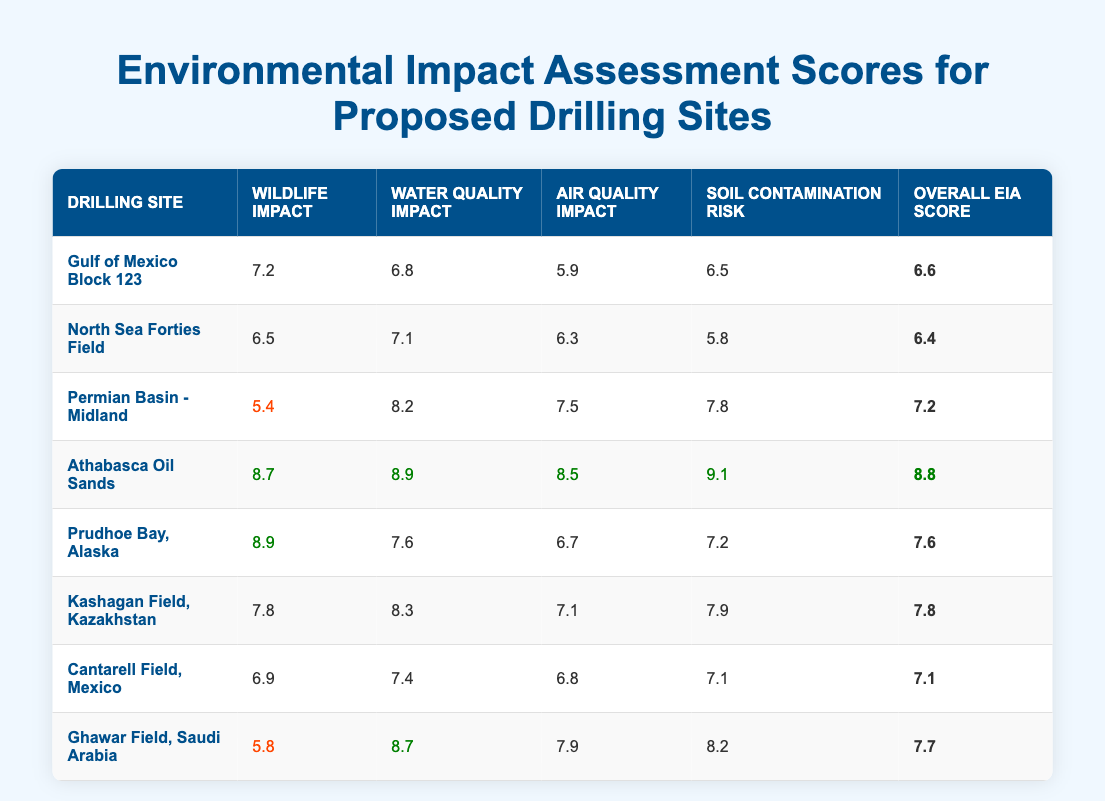What is the Overall EIA Score for the Athabasca Oil Sands? The Overall EIA Score for the Athabasca Oil Sands is provided directly in the table. Looking at the row for Athabasca Oil Sands, the score listed is 8.8.
Answer: 8.8 Which drilling site has the highest Air Quality Impact score? To determine the site with the highest Air Quality Impact score, we look at the Air Quality Impact column and find the maximum value. Athabasca Oil Sands has the highest score of 8.5.
Answer: Athabasca Oil Sands What is the average Wildlife Impact score for all drilling sites? To find the average, we sum the Wildlife Impact scores (7.2 + 6.5 + 5.4 + 8.7 + 8.9 + 7.8 + 6.9 + 5.8) = 56.2. There are 8 drilling sites, so we divide the sum by 8. Thus, the average is 56.2 / 8 = 7.025.
Answer: 7.025 Is the Water Quality Impact for the Gulf of Mexico Block 123 above 6? To answer this, we check the Water Quality Impact score for Gulf of Mexico Block 123. The score is 6.8, which is indeed above 6.
Answer: Yes Which drilling site has the lowest Overall EIA Score? First, we check the Overall EIA Score column for all sites and identify the lowest value listed. The lowest Overall EIA Score is 6.4 for the North Sea Forties Field.
Answer: North Sea Forties Field How does the Soil Contamination Risk compare between the Athabasca Oil Sands and Prudhoe Bay, Alaska? We look at the Soil Contamination Risk scores for both drilling sites. Athabasca Oil Sands has a risk score of 9.1, while Prudhoe Bay has a score of 7.2. Thus, the Athabasca Oil Sands has a higher Soil Contamination Risk by 1.9 points.
Answer: Athabasca Oil Sands has a higher risk What is the total score from Wildlife Impact for the Ghawar Field and the Permian Basin - Midland combined? We add the Wildlife Impact scores for both sites: Ghawar Field has a score of 5.8 and Permian Basin - Midland has a score of 5.4. Thus, the total is 5.8 + 5.4 = 11.2.
Answer: 11.2 Is the Air Quality Impact score for the Ghawar Field higher than 8? The Air Quality Impact score for Ghawar Field is 7.9, which is not higher than 8.
Answer: No Which site has the most balanced environmental scores across all categories? We examine the scores for balance in variability. Athabasca Oil Sands has consistently high scores across all categories, indicating balance since each score is within a narrow range compared to others.
Answer: Athabasca Oil Sands 